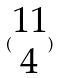<formula> <loc_0><loc_0><loc_500><loc_500>( \begin{matrix} 1 1 \\ 4 \end{matrix} )</formula> 